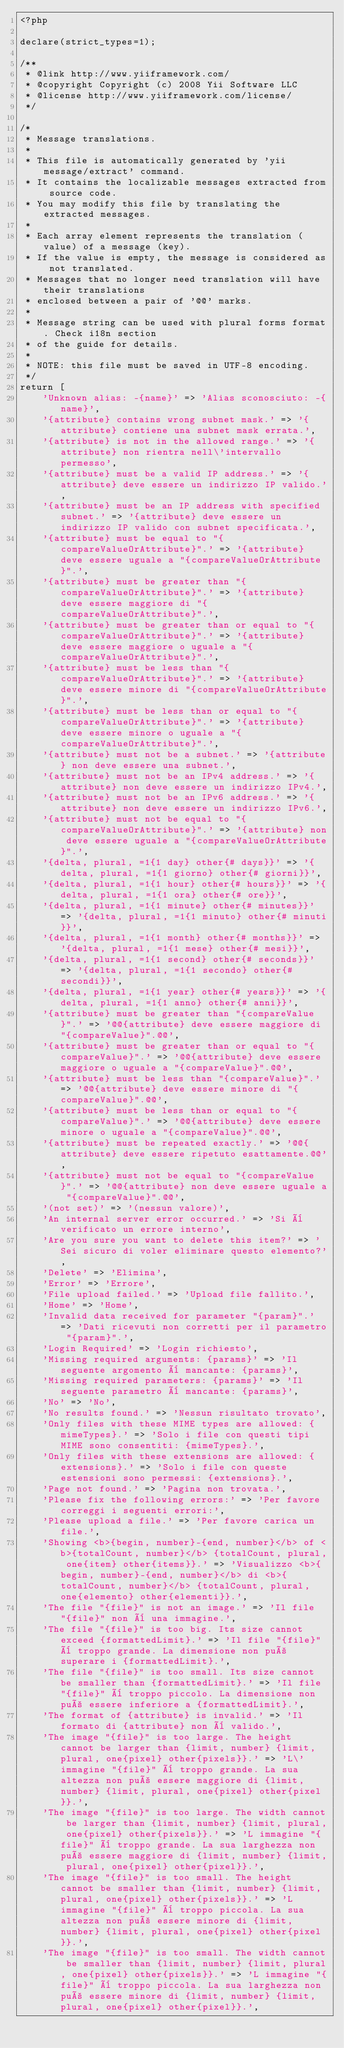Convert code to text. <code><loc_0><loc_0><loc_500><loc_500><_PHP_><?php

declare(strict_types=1);

/**
 * @link http://www.yiiframework.com/
 * @copyright Copyright (c) 2008 Yii Software LLC
 * @license http://www.yiiframework.com/license/
 */

/*
 * Message translations.
 *
 * This file is automatically generated by 'yii message/extract' command.
 * It contains the localizable messages extracted from source code.
 * You may modify this file by translating the extracted messages.
 *
 * Each array element represents the translation (value) of a message (key).
 * If the value is empty, the message is considered as not translated.
 * Messages that no longer need translation will have their translations
 * enclosed between a pair of '@@' marks.
 *
 * Message string can be used with plural forms format. Check i18n section
 * of the guide for details.
 *
 * NOTE: this file must be saved in UTF-8 encoding.
 */
return [
    'Unknown alias: -{name}' => 'Alias sconosciuto: -{name}',
    '{attribute} contains wrong subnet mask.' => '{attribute} contiene una subnet mask errata.',
    '{attribute} is not in the allowed range.' => '{attribute} non rientra nell\'intervallo permesso',
    '{attribute} must be a valid IP address.' => '{attribute} deve essere un indirizzo IP valido.',
    '{attribute} must be an IP address with specified subnet.' => '{attribute} deve essere un indirizzo IP valido con subnet specificata.',
    '{attribute} must be equal to "{compareValueOrAttribute}".' => '{attribute} deve essere uguale a "{compareValueOrAttribute}".',
    '{attribute} must be greater than "{compareValueOrAttribute}".' => '{attribute} deve essere maggiore di "{compareValueOrAttribute}".',
    '{attribute} must be greater than or equal to "{compareValueOrAttribute}".' => '{attribute} deve essere maggiore o uguale a "{compareValueOrAttribute}".',
    '{attribute} must be less than "{compareValueOrAttribute}".' => '{attribute} deve essere minore di "{compareValueOrAttribute}".',
    '{attribute} must be less than or equal to "{compareValueOrAttribute}".' => '{attribute} deve essere minore o uguale a "{compareValueOrAttribute}".',
    '{attribute} must not be a subnet.' => '{attribute} non deve essere una subnet.',
    '{attribute} must not be an IPv4 address.' => '{attribute} non deve essere un indirizzo IPv4.',
    '{attribute} must not be an IPv6 address.' => '{attribute} non deve essere un indirizzo IPv6.',
    '{attribute} must not be equal to "{compareValueOrAttribute}".' => '{attribute} non deve essere uguale a "{compareValueOrAttribute}".',
    '{delta, plural, =1{1 day} other{# days}}' => '{delta, plural, =1{1 giorno} other{# giorni}}',
    '{delta, plural, =1{1 hour} other{# hours}}' => '{delta, plural, =1{1 ora} other{# ore}}',
    '{delta, plural, =1{1 minute} other{# minutes}}' => '{delta, plural, =1{1 minuto} other{# minuti}}',
    '{delta, plural, =1{1 month} other{# months}}' => '{delta, plural, =1{1 mese} other{# mesi}}',
    '{delta, plural, =1{1 second} other{# seconds}}' => '{delta, plural, =1{1 secondo} other{# secondi}}',
    '{delta, plural, =1{1 year} other{# years}}' => '{delta, plural, =1{1 anno} other{# anni}}',
    '{attribute} must be greater than "{compareValue}".' => '@@{attribute} deve essere maggiore di "{compareValue}".@@',
    '{attribute} must be greater than or equal to "{compareValue}".' => '@@{attribute} deve essere maggiore o uguale a "{compareValue}".@@',
    '{attribute} must be less than "{compareValue}".' => '@@{attribute} deve essere minore di "{compareValue}".@@',
    '{attribute} must be less than or equal to "{compareValue}".' => '@@{attribute} deve essere minore o uguale a "{compareValue}".@@',
    '{attribute} must be repeated exactly.' => '@@{attribute} deve essere ripetuto esattamente.@@',
    '{attribute} must not be equal to "{compareValue}".' => '@@{attribute} non deve essere uguale a "{compareValue}".@@',
    '(not set)' => '(nessun valore)',
    'An internal server error occurred.' => 'Si è verificato un errore interno',
    'Are you sure you want to delete this item?' => 'Sei sicuro di voler eliminare questo elemento?',
    'Delete' => 'Elimina',
    'Error' => 'Errore',
    'File upload failed.' => 'Upload file fallito.',
    'Home' => 'Home',
    'Invalid data received for parameter "{param}".' => 'Dati ricevuti non corretti per il parametro "{param}".',
    'Login Required' => 'Login richiesto',
    'Missing required arguments: {params}' => 'Il seguente argomento è mancante: {params}',
    'Missing required parameters: {params}' => 'Il seguente parametro è mancante: {params}',
    'No' => 'No',
    'No results found.' => 'Nessun risultato trovato',
    'Only files with these MIME types are allowed: {mimeTypes}.' => 'Solo i file con questi tipi MIME sono consentiti: {mimeTypes}.',
    'Only files with these extensions are allowed: {extensions}.' => 'Solo i file con queste estensioni sono permessi: {extensions}.',
    'Page not found.' => 'Pagina non trovata.',
    'Please fix the following errors:' => 'Per favore correggi i seguenti errori:',
    'Please upload a file.' => 'Per favore carica un file.',
    'Showing <b>{begin, number}-{end, number}</b> of <b>{totalCount, number}</b> {totalCount, plural, one{item} other{items}}.' => 'Visualizzo <b>{begin, number}-{end, number}</b> di <b>{totalCount, number}</b> {totalCount, plural, one{elemento} other{elementi}}.',
    'The file "{file}" is not an image.' => 'Il file "{file}" non è una immagine.',
    'The file "{file}" is too big. Its size cannot exceed {formattedLimit}.' => 'Il file "{file}" è troppo grande. La dimensione non può superare i {formattedLimit}.',
    'The file "{file}" is too small. Its size cannot be smaller than {formattedLimit}.' => 'Il file "{file}" è troppo piccolo. La dimensione non può essere inferiore a {formattedLimit}.',
    'The format of {attribute} is invalid.' => 'Il formato di {attribute} non è valido.',
    'The image "{file}" is too large. The height cannot be larger than {limit, number} {limit, plural, one{pixel} other{pixels}}.' => 'L\'immagine "{file}" è troppo grande. La sua altezza non può essere maggiore di {limit, number} {limit, plural, one{pixel} other{pixel}}.',
    'The image "{file}" is too large. The width cannot be larger than {limit, number} {limit, plural, one{pixel} other{pixels}}.' => 'L immagine "{file}" è troppo grande. La sua larghezza non può essere maggiore di {limit, number} {limit, plural, one{pixel} other{pixel}}.',
    'The image "{file}" is too small. The height cannot be smaller than {limit, number} {limit, plural, one{pixel} other{pixels}}.' => 'L immagine "{file}" è troppo piccola. La sua altezza non può essere minore di {limit, number} {limit, plural, one{pixel} other{pixel}}.',
    'The image "{file}" is too small. The width cannot be smaller than {limit, number} {limit, plural, one{pixel} other{pixels}}.' => 'L immagine "{file}" è troppo piccola. La sua larghezza non può essere minore di {limit, number} {limit, plural, one{pixel} other{pixel}}.',</code> 